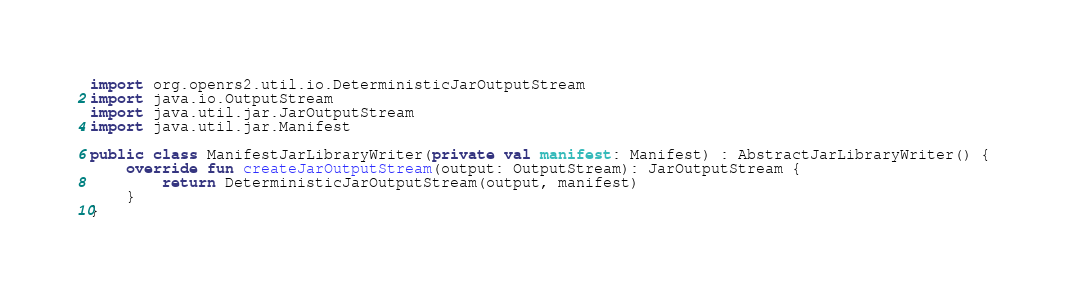<code> <loc_0><loc_0><loc_500><loc_500><_Kotlin_>
import org.openrs2.util.io.DeterministicJarOutputStream
import java.io.OutputStream
import java.util.jar.JarOutputStream
import java.util.jar.Manifest

public class ManifestJarLibraryWriter(private val manifest: Manifest) : AbstractJarLibraryWriter() {
    override fun createJarOutputStream(output: OutputStream): JarOutputStream {
        return DeterministicJarOutputStream(output, manifest)
    }
}
</code> 